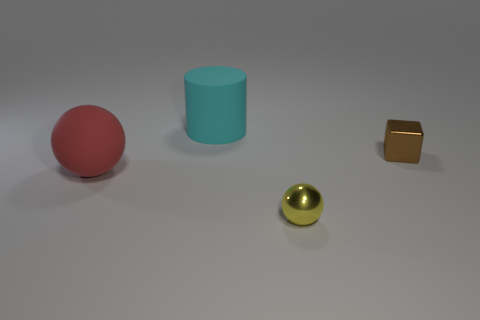Add 3 big brown matte objects. How many objects exist? 7 Subtract all cubes. How many objects are left? 3 Add 2 red metallic cylinders. How many red metallic cylinders exist? 2 Subtract 0 yellow cubes. How many objects are left? 4 Subtract all large purple metal cubes. Subtract all big matte objects. How many objects are left? 2 Add 2 big matte things. How many big matte things are left? 4 